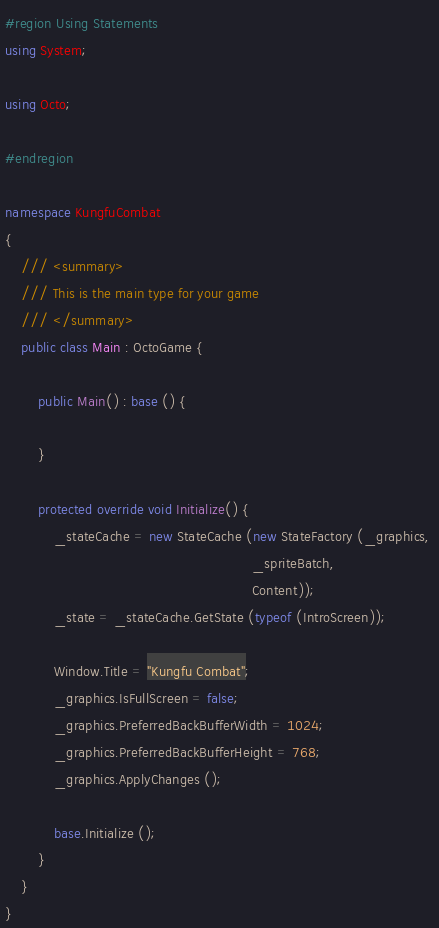Convert code to text. <code><loc_0><loc_0><loc_500><loc_500><_C#_>#region Using Statements
using System;

using Octo;

#endregion

namespace KungfuCombat
{
    /// <summary>
    /// This is the main type for your game
    /// </summary>
    public class Main : OctoGame {

        public Main() : base () {

        }

        protected override void Initialize() {
            _stateCache = new StateCache (new StateFactory (_graphics, 
                                                            _spriteBatch,
                                                            Content));
            _state = _stateCache.GetState (typeof (IntroScreen));

            Window.Title = "Kungfu Combat";
            _graphics.IsFullScreen = false;
            _graphics.PreferredBackBufferWidth = 1024;
            _graphics.PreferredBackBufferHeight = 768;
            _graphics.ApplyChanges ();

            base.Initialize ();
        }
    }
}
</code> 